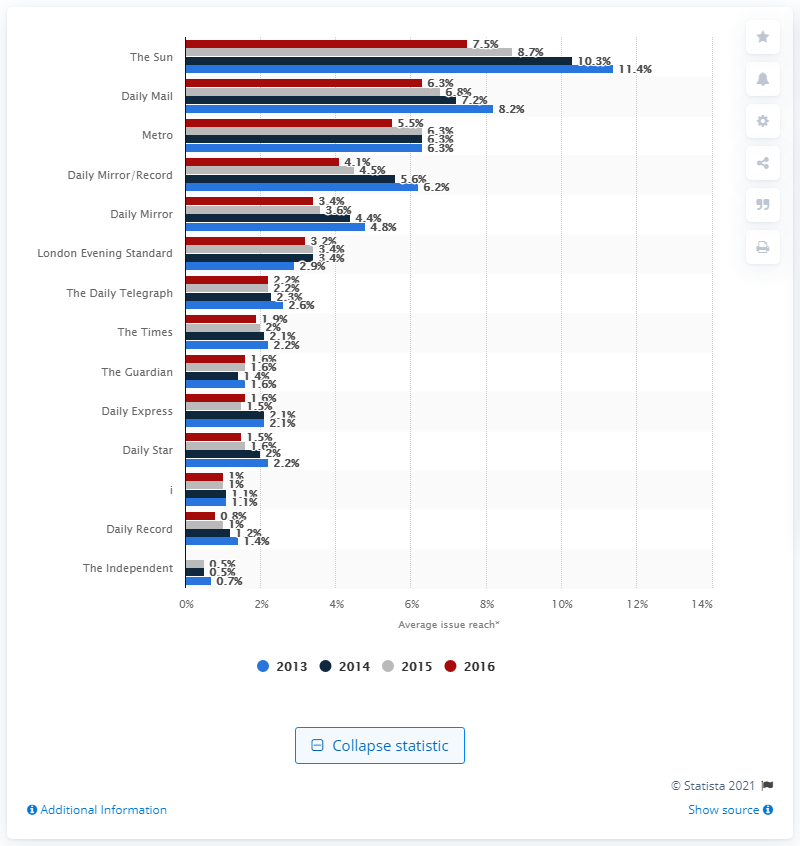Indicate a few pertinent items in this graphic. The Sun was the newspaper that had the highest penetration of the UK population aged 15 and over for at least 15 years. 